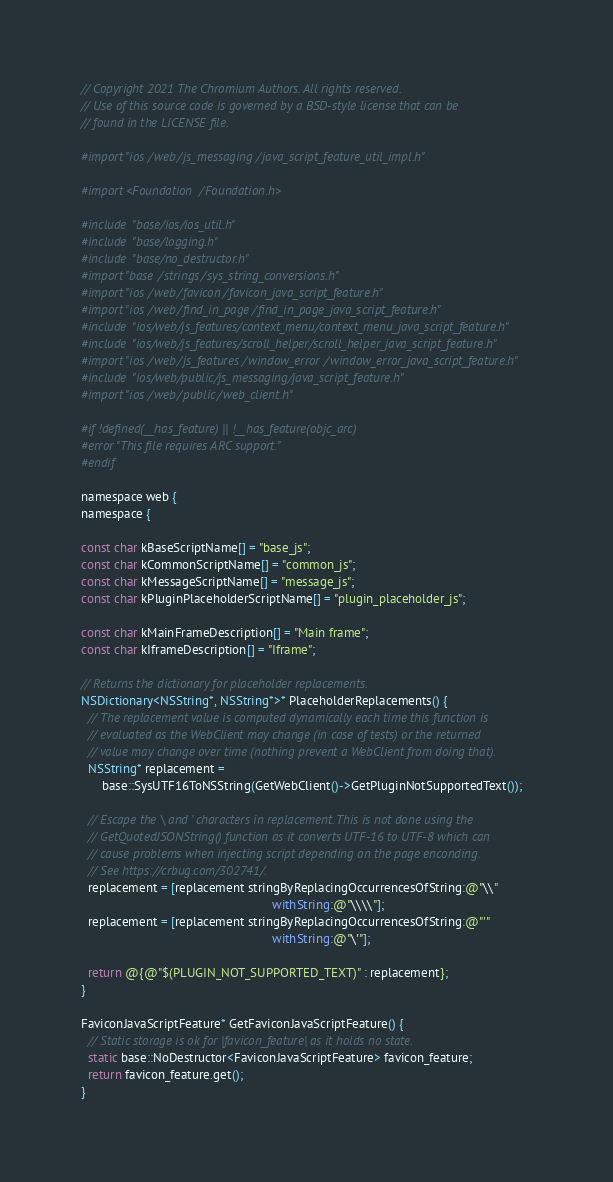<code> <loc_0><loc_0><loc_500><loc_500><_ObjectiveC_>// Copyright 2021 The Chromium Authors. All rights reserved.
// Use of this source code is governed by a BSD-style license that can be
// found in the LICENSE file.

#import "ios/web/js_messaging/java_script_feature_util_impl.h"

#import <Foundation/Foundation.h>

#include "base/ios/ios_util.h"
#include "base/logging.h"
#include "base/no_destructor.h"
#import "base/strings/sys_string_conversions.h"
#import "ios/web/favicon/favicon_java_script_feature.h"
#import "ios/web/find_in_page/find_in_page_java_script_feature.h"
#include "ios/web/js_features/context_menu/context_menu_java_script_feature.h"
#include "ios/web/js_features/scroll_helper/scroll_helper_java_script_feature.h"
#import "ios/web/js_features/window_error/window_error_java_script_feature.h"
#include "ios/web/public/js_messaging/java_script_feature.h"
#import "ios/web/public/web_client.h"

#if !defined(__has_feature) || !__has_feature(objc_arc)
#error "This file requires ARC support."
#endif

namespace web {
namespace {

const char kBaseScriptName[] = "base_js";
const char kCommonScriptName[] = "common_js";
const char kMessageScriptName[] = "message_js";
const char kPluginPlaceholderScriptName[] = "plugin_placeholder_js";

const char kMainFrameDescription[] = "Main frame";
const char kIframeDescription[] = "Iframe";

// Returns the dictionary for placeholder replacements.
NSDictionary<NSString*, NSString*>* PlaceholderReplacements() {
  // The replacement value is computed dynamically each time this function is
  // evaluated as the WebClient may change (in case of tests) or the returned
  // value may change over time (nothing prevent a WebClient from doing that).
  NSString* replacement =
      base::SysUTF16ToNSString(GetWebClient()->GetPluginNotSupportedText());

  // Escape the \ and ' characters in replacement. This is not done using the
  // GetQuotedJSONString() function as it converts UTF-16 to UTF-8 which can
  // cause problems when injecting script depending on the page enconding.
  // See https://crbug.com/302741/.
  replacement = [replacement stringByReplacingOccurrencesOfString:@"\\"
                                                       withString:@"\\\\"];
  replacement = [replacement stringByReplacingOccurrencesOfString:@"'"
                                                       withString:@"\'"];

  return @{@"$(PLUGIN_NOT_SUPPORTED_TEXT)" : replacement};
}

FaviconJavaScriptFeature* GetFaviconJavaScriptFeature() {
  // Static storage is ok for |favicon_feature| as it holds no state.
  static base::NoDestructor<FaviconJavaScriptFeature> favicon_feature;
  return favicon_feature.get();
}
</code> 